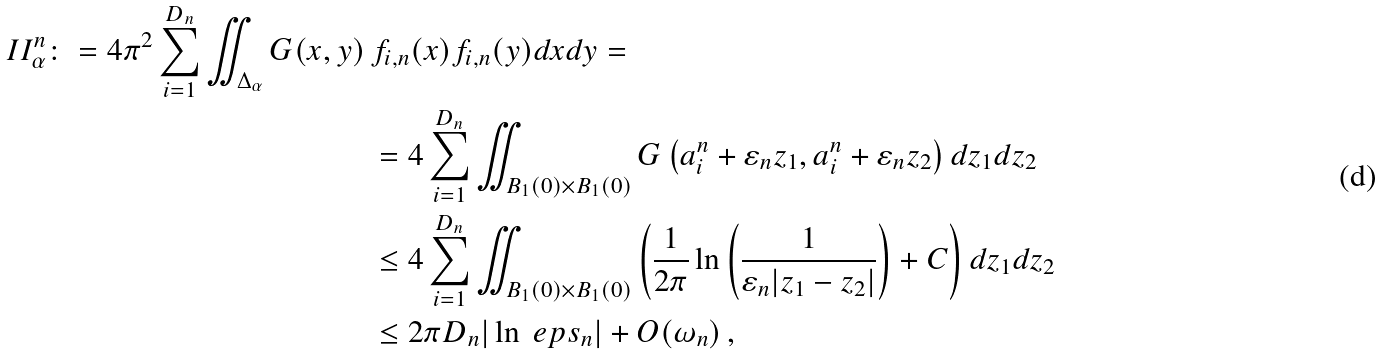Convert formula to latex. <formula><loc_0><loc_0><loc_500><loc_500>I I ^ { n } _ { \alpha } \colon = 4 \pi ^ { 2 } \sum _ { i = 1 } ^ { D _ { n } } \iint _ { \Delta _ { \alpha } } G ( x , y ) \, & f _ { i , n } ( x ) f _ { i , n } ( y ) d x d y = \\ & = 4 \sum _ { i = 1 } ^ { D _ { n } } \iint _ { B _ { 1 } ( 0 ) \times B _ { 1 } ( 0 ) } G \left ( a _ { i } ^ { n } + \varepsilon _ { n } z _ { 1 } , a _ { i } ^ { n } + \varepsilon _ { n } z _ { 2 } \right ) d z _ { 1 } d z _ { 2 } \\ & \leq 4 \sum _ { i = 1 } ^ { D _ { n } } \iint _ { B _ { 1 } ( 0 ) \times B _ { 1 } ( 0 ) } \left ( \frac { 1 } { 2 \pi } \ln \left ( \frac { 1 } { \varepsilon _ { n } | z _ { 1 } - z _ { 2 } | } \right ) + C \right ) d z _ { 1 } d z _ { 2 } \\ & \leq 2 \pi D _ { n } | \ln \ e p s _ { n } | + O ( \omega _ { n } ) \, ,</formula> 